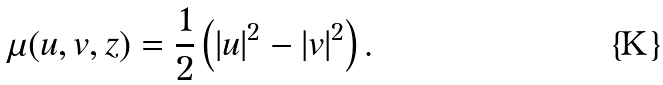<formula> <loc_0><loc_0><loc_500><loc_500>\mu ( u , v , z ) = \frac { 1 } { 2 } \left ( | u | ^ { 2 } - | v | ^ { 2 } \right ) .</formula> 